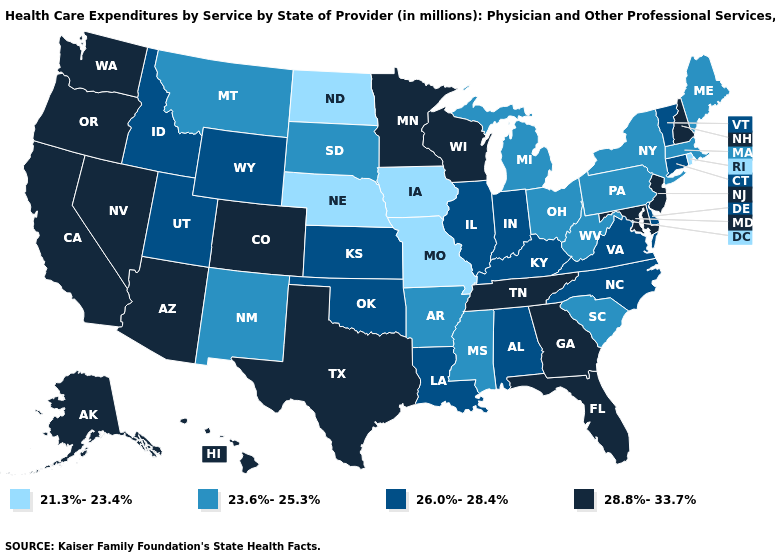How many symbols are there in the legend?
Be succinct. 4. Name the states that have a value in the range 23.6%-25.3%?
Answer briefly. Arkansas, Maine, Massachusetts, Michigan, Mississippi, Montana, New Mexico, New York, Ohio, Pennsylvania, South Carolina, South Dakota, West Virginia. What is the value of Louisiana?
Keep it brief. 26.0%-28.4%. Among the states that border California , which have the highest value?
Write a very short answer. Arizona, Nevada, Oregon. Name the states that have a value in the range 28.8%-33.7%?
Write a very short answer. Alaska, Arizona, California, Colorado, Florida, Georgia, Hawaii, Maryland, Minnesota, Nevada, New Hampshire, New Jersey, Oregon, Tennessee, Texas, Washington, Wisconsin. Does the map have missing data?
Short answer required. No. Does Connecticut have the highest value in the Northeast?
Give a very brief answer. No. Name the states that have a value in the range 21.3%-23.4%?
Be succinct. Iowa, Missouri, Nebraska, North Dakota, Rhode Island. Does Virginia have a lower value than New Hampshire?
Keep it brief. Yes. Among the states that border Virginia , which have the lowest value?
Give a very brief answer. West Virginia. What is the lowest value in states that border New Jersey?
Write a very short answer. 23.6%-25.3%. What is the value of Maryland?
Give a very brief answer. 28.8%-33.7%. What is the value of New Hampshire?
Quick response, please. 28.8%-33.7%. What is the highest value in the USA?
Answer briefly. 28.8%-33.7%. 